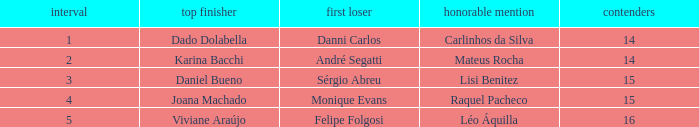How many contestants were there when the runner-up was Sérgio Abreu?  15.0. 